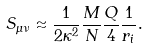Convert formula to latex. <formula><loc_0><loc_0><loc_500><loc_500>S _ { \mu \nu } \approx \frac { 1 } { 2 \kappa ^ { 2 } } \frac { M } { N } \frac { Q } { 4 } \frac { 1 } { r _ { i } } .</formula> 